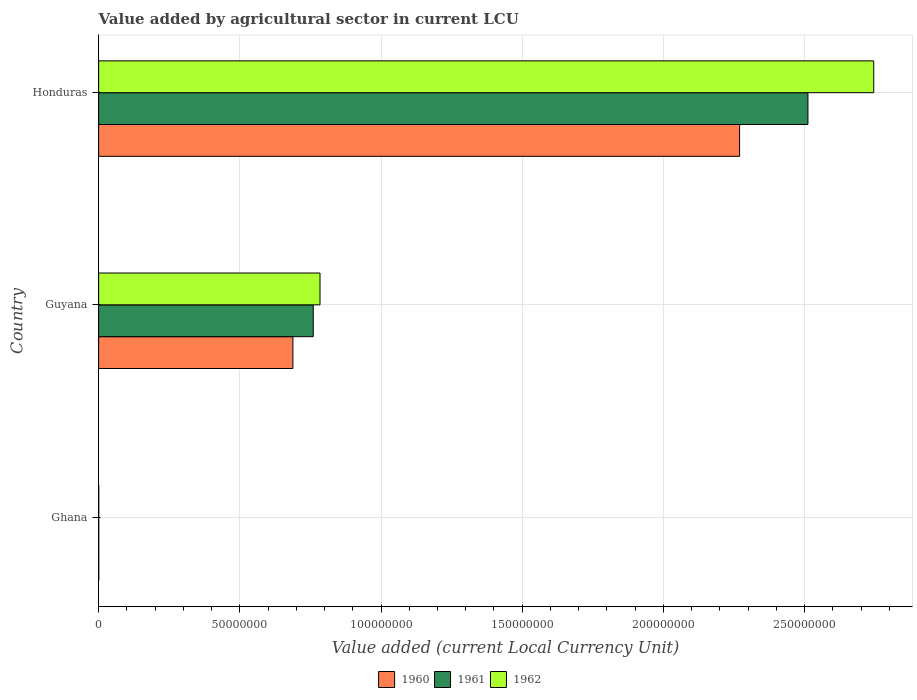Are the number of bars per tick equal to the number of legend labels?
Provide a succinct answer. Yes. Are the number of bars on each tick of the Y-axis equal?
Keep it short and to the point. Yes. What is the label of the 3rd group of bars from the top?
Offer a terse response. Ghana. In how many cases, is the number of bars for a given country not equal to the number of legend labels?
Offer a very short reply. 0. What is the value added by agricultural sector in 1960 in Ghana?
Your answer should be compact. 3.55e+04. Across all countries, what is the maximum value added by agricultural sector in 1962?
Provide a succinct answer. 2.74e+08. Across all countries, what is the minimum value added by agricultural sector in 1960?
Your answer should be compact. 3.55e+04. In which country was the value added by agricultural sector in 1961 maximum?
Offer a very short reply. Honduras. In which country was the value added by agricultural sector in 1962 minimum?
Offer a very short reply. Ghana. What is the total value added by agricultural sector in 1961 in the graph?
Give a very brief answer. 3.27e+08. What is the difference between the value added by agricultural sector in 1961 in Ghana and that in Honduras?
Ensure brevity in your answer.  -2.51e+08. What is the difference between the value added by agricultural sector in 1962 in Honduras and the value added by agricultural sector in 1960 in Ghana?
Make the answer very short. 2.74e+08. What is the average value added by agricultural sector in 1962 per country?
Provide a succinct answer. 1.18e+08. What is the difference between the value added by agricultural sector in 1961 and value added by agricultural sector in 1962 in Guyana?
Your answer should be very brief. -2.40e+06. In how many countries, is the value added by agricultural sector in 1960 greater than 90000000 LCU?
Provide a succinct answer. 1. What is the ratio of the value added by agricultural sector in 1961 in Ghana to that in Guyana?
Keep it short and to the point. 0. Is the difference between the value added by agricultural sector in 1961 in Ghana and Honduras greater than the difference between the value added by agricultural sector in 1962 in Ghana and Honduras?
Provide a short and direct response. Yes. What is the difference between the highest and the second highest value added by agricultural sector in 1962?
Your answer should be compact. 1.96e+08. What is the difference between the highest and the lowest value added by agricultural sector in 1960?
Your answer should be compact. 2.27e+08. Is the sum of the value added by agricultural sector in 1960 in Ghana and Guyana greater than the maximum value added by agricultural sector in 1962 across all countries?
Your response must be concise. No. How many bars are there?
Your response must be concise. 9. Does the graph contain grids?
Keep it short and to the point. Yes. Where does the legend appear in the graph?
Your response must be concise. Bottom center. How are the legend labels stacked?
Keep it short and to the point. Horizontal. What is the title of the graph?
Ensure brevity in your answer.  Value added by agricultural sector in current LCU. What is the label or title of the X-axis?
Offer a terse response. Value added (current Local Currency Unit). What is the Value added (current Local Currency Unit) of 1960 in Ghana?
Keep it short and to the point. 3.55e+04. What is the Value added (current Local Currency Unit) in 1961 in Ghana?
Offer a very short reply. 3.29e+04. What is the Value added (current Local Currency Unit) in 1962 in Ghana?
Offer a terse response. 3.74e+04. What is the Value added (current Local Currency Unit) of 1960 in Guyana?
Your response must be concise. 6.88e+07. What is the Value added (current Local Currency Unit) of 1961 in Guyana?
Your answer should be compact. 7.60e+07. What is the Value added (current Local Currency Unit) in 1962 in Guyana?
Offer a very short reply. 7.84e+07. What is the Value added (current Local Currency Unit) in 1960 in Honduras?
Your answer should be very brief. 2.27e+08. What is the Value added (current Local Currency Unit) of 1961 in Honduras?
Offer a terse response. 2.51e+08. What is the Value added (current Local Currency Unit) in 1962 in Honduras?
Offer a very short reply. 2.74e+08. Across all countries, what is the maximum Value added (current Local Currency Unit) in 1960?
Offer a terse response. 2.27e+08. Across all countries, what is the maximum Value added (current Local Currency Unit) in 1961?
Your response must be concise. 2.51e+08. Across all countries, what is the maximum Value added (current Local Currency Unit) of 1962?
Your response must be concise. 2.74e+08. Across all countries, what is the minimum Value added (current Local Currency Unit) of 1960?
Offer a very short reply. 3.55e+04. Across all countries, what is the minimum Value added (current Local Currency Unit) of 1961?
Your answer should be compact. 3.29e+04. Across all countries, what is the minimum Value added (current Local Currency Unit) in 1962?
Provide a succinct answer. 3.74e+04. What is the total Value added (current Local Currency Unit) of 1960 in the graph?
Keep it short and to the point. 2.96e+08. What is the total Value added (current Local Currency Unit) in 1961 in the graph?
Make the answer very short. 3.27e+08. What is the total Value added (current Local Currency Unit) in 1962 in the graph?
Give a very brief answer. 3.53e+08. What is the difference between the Value added (current Local Currency Unit) in 1960 in Ghana and that in Guyana?
Offer a very short reply. -6.88e+07. What is the difference between the Value added (current Local Currency Unit) in 1961 in Ghana and that in Guyana?
Your answer should be compact. -7.60e+07. What is the difference between the Value added (current Local Currency Unit) of 1962 in Ghana and that in Guyana?
Give a very brief answer. -7.84e+07. What is the difference between the Value added (current Local Currency Unit) of 1960 in Ghana and that in Honduras?
Offer a very short reply. -2.27e+08. What is the difference between the Value added (current Local Currency Unit) in 1961 in Ghana and that in Honduras?
Keep it short and to the point. -2.51e+08. What is the difference between the Value added (current Local Currency Unit) of 1962 in Ghana and that in Honduras?
Make the answer very short. -2.74e+08. What is the difference between the Value added (current Local Currency Unit) in 1960 in Guyana and that in Honduras?
Your response must be concise. -1.58e+08. What is the difference between the Value added (current Local Currency Unit) of 1961 in Guyana and that in Honduras?
Your response must be concise. -1.75e+08. What is the difference between the Value added (current Local Currency Unit) of 1962 in Guyana and that in Honduras?
Keep it short and to the point. -1.96e+08. What is the difference between the Value added (current Local Currency Unit) of 1960 in Ghana and the Value added (current Local Currency Unit) of 1961 in Guyana?
Give a very brief answer. -7.60e+07. What is the difference between the Value added (current Local Currency Unit) in 1960 in Ghana and the Value added (current Local Currency Unit) in 1962 in Guyana?
Offer a terse response. -7.84e+07. What is the difference between the Value added (current Local Currency Unit) in 1961 in Ghana and the Value added (current Local Currency Unit) in 1962 in Guyana?
Make the answer very short. -7.84e+07. What is the difference between the Value added (current Local Currency Unit) of 1960 in Ghana and the Value added (current Local Currency Unit) of 1961 in Honduras?
Give a very brief answer. -2.51e+08. What is the difference between the Value added (current Local Currency Unit) in 1960 in Ghana and the Value added (current Local Currency Unit) in 1962 in Honduras?
Your answer should be very brief. -2.74e+08. What is the difference between the Value added (current Local Currency Unit) in 1961 in Ghana and the Value added (current Local Currency Unit) in 1962 in Honduras?
Provide a succinct answer. -2.74e+08. What is the difference between the Value added (current Local Currency Unit) in 1960 in Guyana and the Value added (current Local Currency Unit) in 1961 in Honduras?
Ensure brevity in your answer.  -1.82e+08. What is the difference between the Value added (current Local Currency Unit) in 1960 in Guyana and the Value added (current Local Currency Unit) in 1962 in Honduras?
Your response must be concise. -2.06e+08. What is the difference between the Value added (current Local Currency Unit) in 1961 in Guyana and the Value added (current Local Currency Unit) in 1962 in Honduras?
Make the answer very short. -1.98e+08. What is the average Value added (current Local Currency Unit) in 1960 per country?
Provide a succinct answer. 9.86e+07. What is the average Value added (current Local Currency Unit) of 1961 per country?
Offer a terse response. 1.09e+08. What is the average Value added (current Local Currency Unit) of 1962 per country?
Your answer should be very brief. 1.18e+08. What is the difference between the Value added (current Local Currency Unit) in 1960 and Value added (current Local Currency Unit) in 1961 in Ghana?
Ensure brevity in your answer.  2600. What is the difference between the Value added (current Local Currency Unit) of 1960 and Value added (current Local Currency Unit) of 1962 in Ghana?
Provide a short and direct response. -1900. What is the difference between the Value added (current Local Currency Unit) in 1961 and Value added (current Local Currency Unit) in 1962 in Ghana?
Provide a succinct answer. -4500. What is the difference between the Value added (current Local Currency Unit) in 1960 and Value added (current Local Currency Unit) in 1961 in Guyana?
Your answer should be very brief. -7.20e+06. What is the difference between the Value added (current Local Currency Unit) of 1960 and Value added (current Local Currency Unit) of 1962 in Guyana?
Offer a terse response. -9.60e+06. What is the difference between the Value added (current Local Currency Unit) of 1961 and Value added (current Local Currency Unit) of 1962 in Guyana?
Your answer should be very brief. -2.40e+06. What is the difference between the Value added (current Local Currency Unit) of 1960 and Value added (current Local Currency Unit) of 1961 in Honduras?
Make the answer very short. -2.42e+07. What is the difference between the Value added (current Local Currency Unit) in 1960 and Value added (current Local Currency Unit) in 1962 in Honduras?
Make the answer very short. -4.75e+07. What is the difference between the Value added (current Local Currency Unit) of 1961 and Value added (current Local Currency Unit) of 1962 in Honduras?
Ensure brevity in your answer.  -2.33e+07. What is the ratio of the Value added (current Local Currency Unit) of 1960 in Ghana to that in Guyana?
Make the answer very short. 0. What is the ratio of the Value added (current Local Currency Unit) in 1961 in Ghana to that in Guyana?
Offer a very short reply. 0. What is the ratio of the Value added (current Local Currency Unit) of 1962 in Ghana to that in Honduras?
Provide a succinct answer. 0. What is the ratio of the Value added (current Local Currency Unit) in 1960 in Guyana to that in Honduras?
Your answer should be very brief. 0.3. What is the ratio of the Value added (current Local Currency Unit) of 1961 in Guyana to that in Honduras?
Ensure brevity in your answer.  0.3. What is the ratio of the Value added (current Local Currency Unit) of 1962 in Guyana to that in Honduras?
Your answer should be compact. 0.29. What is the difference between the highest and the second highest Value added (current Local Currency Unit) of 1960?
Keep it short and to the point. 1.58e+08. What is the difference between the highest and the second highest Value added (current Local Currency Unit) of 1961?
Offer a terse response. 1.75e+08. What is the difference between the highest and the second highest Value added (current Local Currency Unit) in 1962?
Give a very brief answer. 1.96e+08. What is the difference between the highest and the lowest Value added (current Local Currency Unit) of 1960?
Give a very brief answer. 2.27e+08. What is the difference between the highest and the lowest Value added (current Local Currency Unit) in 1961?
Your answer should be very brief. 2.51e+08. What is the difference between the highest and the lowest Value added (current Local Currency Unit) in 1962?
Offer a very short reply. 2.74e+08. 